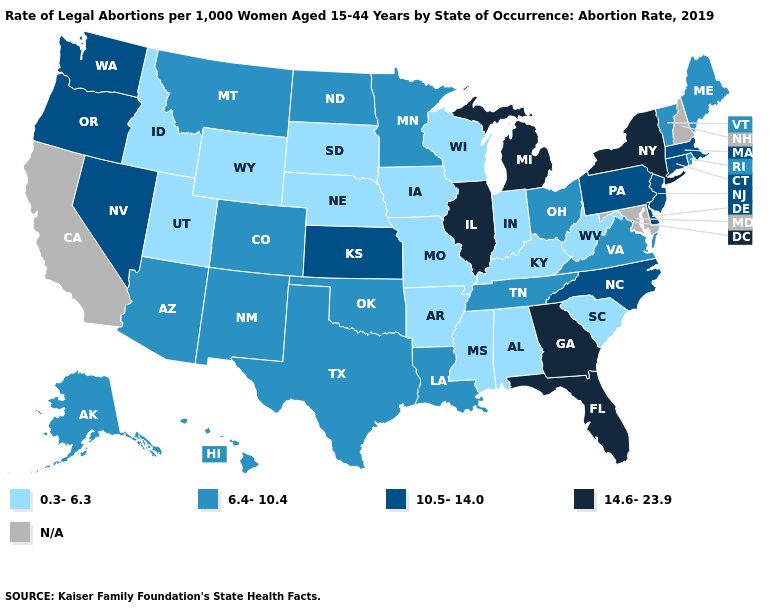Name the states that have a value in the range 0.3-6.3?
Keep it brief. Alabama, Arkansas, Idaho, Indiana, Iowa, Kentucky, Mississippi, Missouri, Nebraska, South Carolina, South Dakota, Utah, West Virginia, Wisconsin, Wyoming. Which states have the lowest value in the West?
Be succinct. Idaho, Utah, Wyoming. Among the states that border Mississippi , which have the lowest value?
Keep it brief. Alabama, Arkansas. What is the value of Montana?
Give a very brief answer. 6.4-10.4. Which states have the lowest value in the West?
Quick response, please. Idaho, Utah, Wyoming. What is the value of North Carolina?
Concise answer only. 10.5-14.0. What is the value of Kentucky?
Concise answer only. 0.3-6.3. What is the lowest value in the West?
Quick response, please. 0.3-6.3. Name the states that have a value in the range N/A?
Short answer required. California, Maryland, New Hampshire. What is the lowest value in the USA?
Be succinct. 0.3-6.3. What is the value of Georgia?
Short answer required. 14.6-23.9. Name the states that have a value in the range 14.6-23.9?
Answer briefly. Florida, Georgia, Illinois, Michigan, New York. Which states hav the highest value in the MidWest?
Quick response, please. Illinois, Michigan. What is the value of Washington?
Be succinct. 10.5-14.0. 